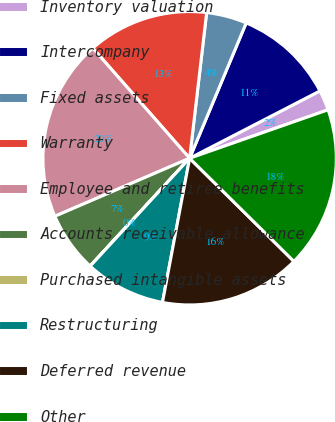Convert chart to OTSL. <chart><loc_0><loc_0><loc_500><loc_500><pie_chart><fcel>Inventory valuation<fcel>Intercompany<fcel>Fixed assets<fcel>Warranty<fcel>Employee and retiree benefits<fcel>Accounts receivable allowance<fcel>Purchased intangible assets<fcel>Restructuring<fcel>Deferred revenue<fcel>Other<nl><fcel>2.23%<fcel>11.11%<fcel>4.45%<fcel>13.33%<fcel>19.99%<fcel>6.67%<fcel>0.01%<fcel>8.89%<fcel>15.55%<fcel>17.77%<nl></chart> 